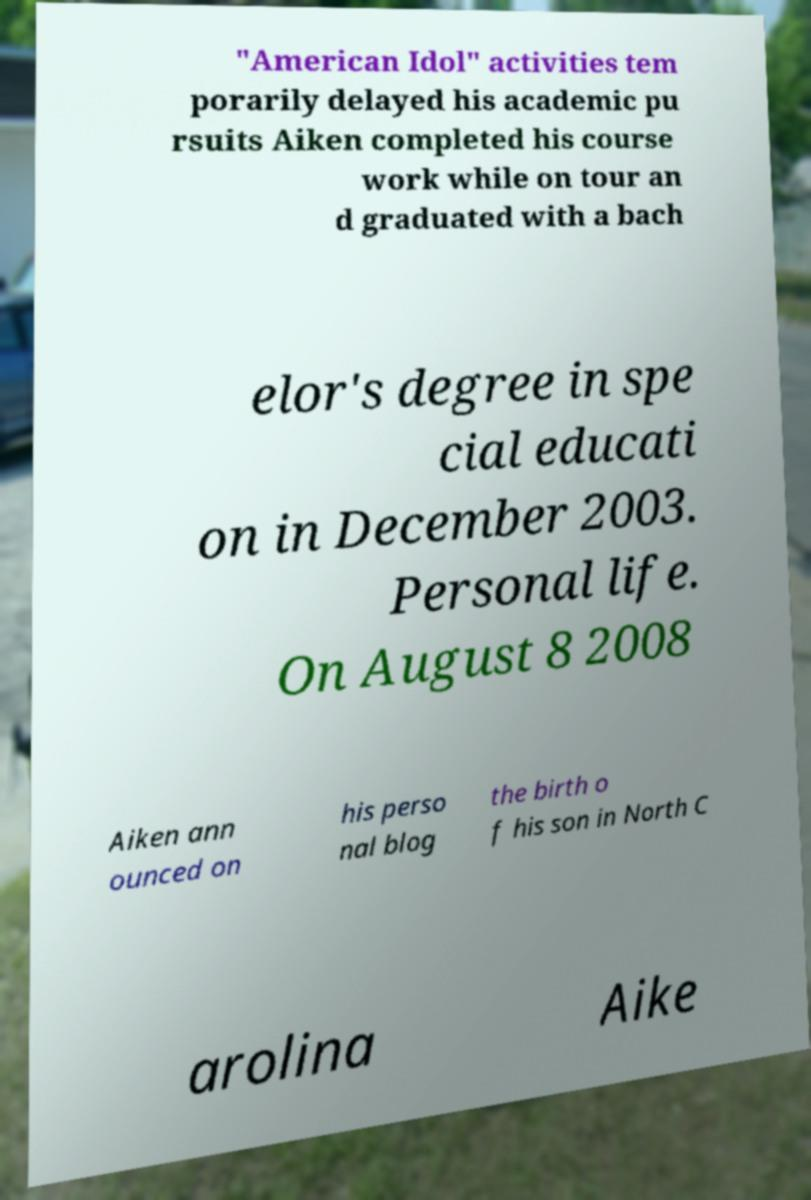Can you accurately transcribe the text from the provided image for me? "American Idol" activities tem porarily delayed his academic pu rsuits Aiken completed his course work while on tour an d graduated with a bach elor's degree in spe cial educati on in December 2003. Personal life. On August 8 2008 Aiken ann ounced on his perso nal blog the birth o f his son in North C arolina Aike 